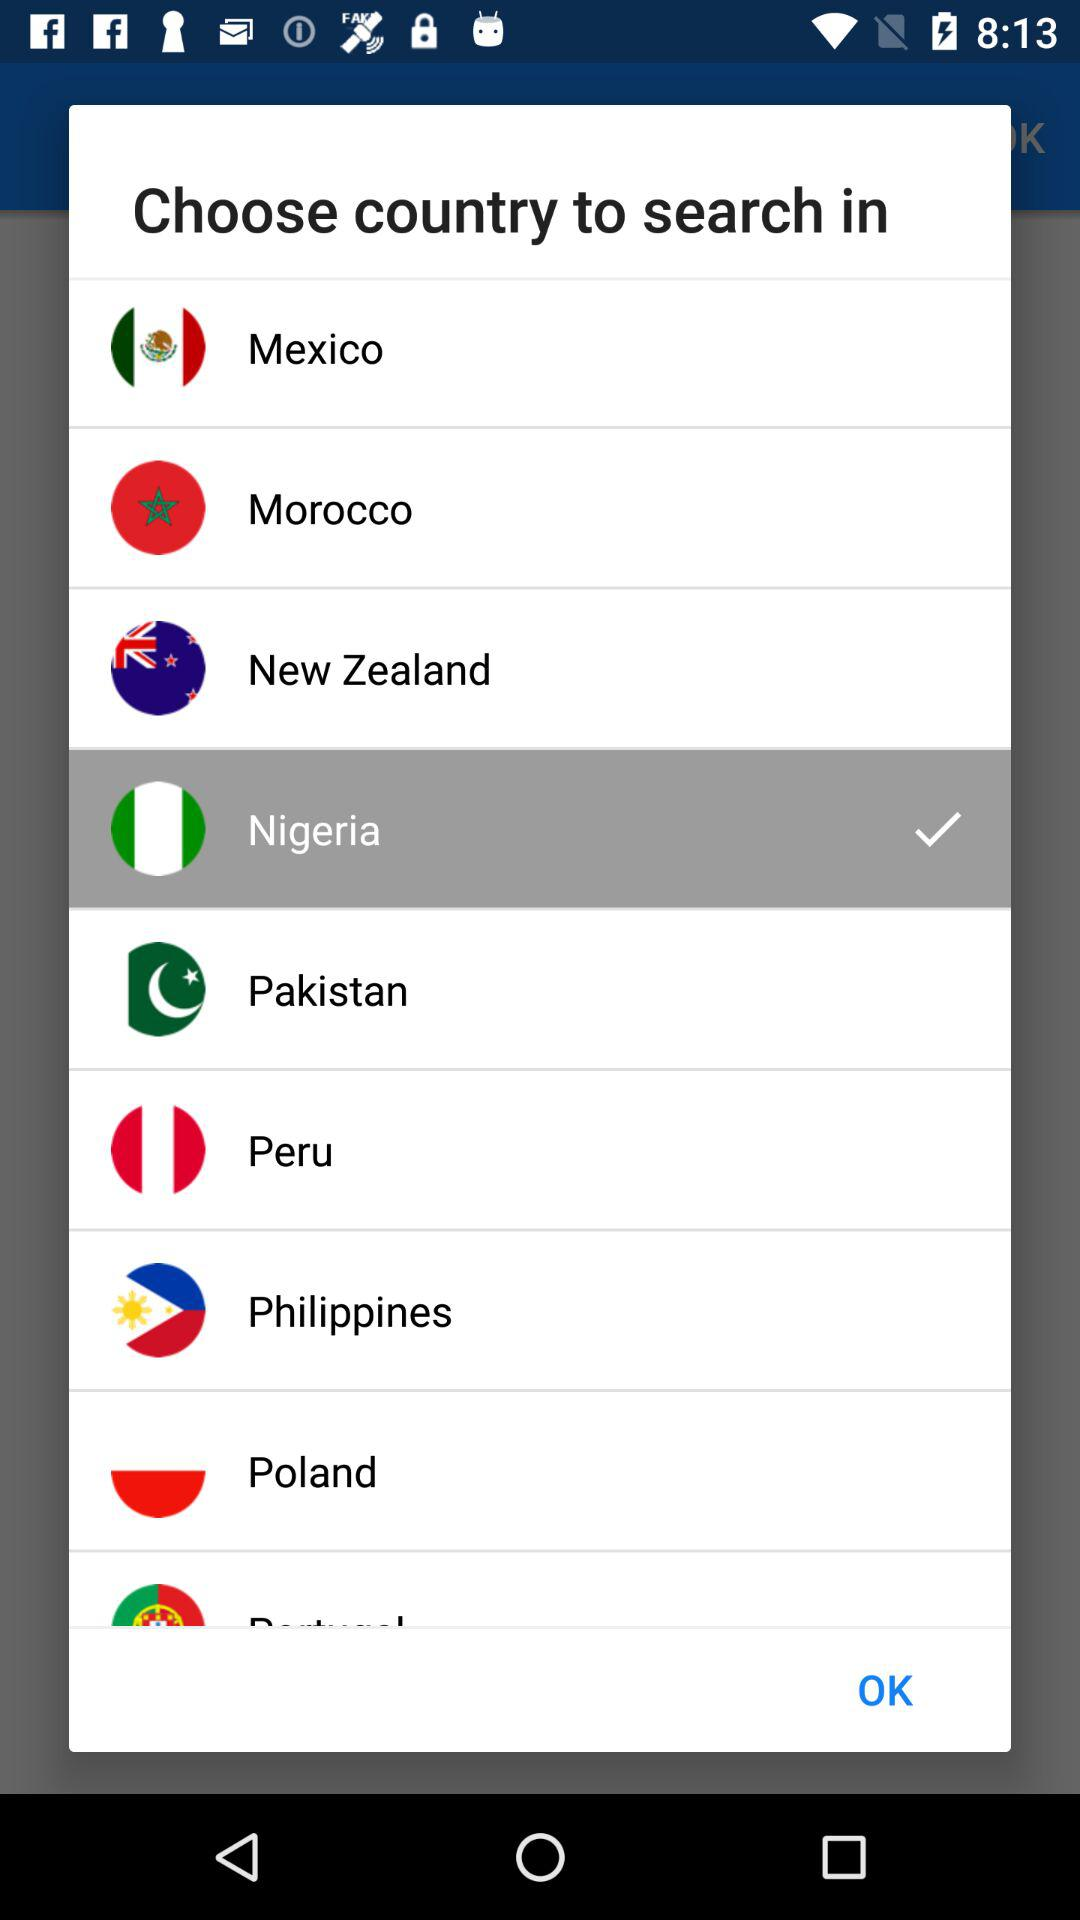What is the name of the application?
When the provided information is insufficient, respond with <no answer>. <no answer> 